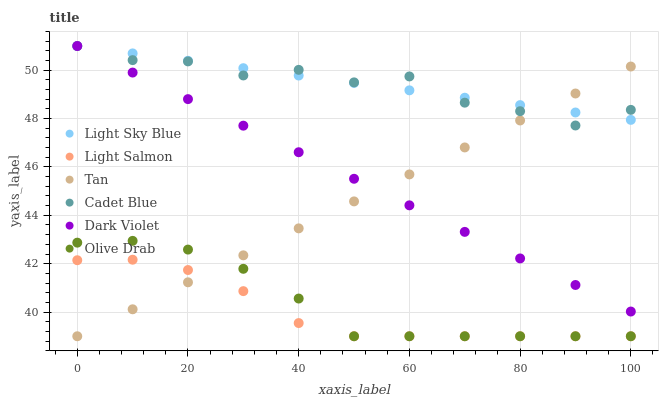Does Light Salmon have the minimum area under the curve?
Answer yes or no. Yes. Does Light Sky Blue have the maximum area under the curve?
Answer yes or no. Yes. Does Cadet Blue have the minimum area under the curve?
Answer yes or no. No. Does Cadet Blue have the maximum area under the curve?
Answer yes or no. No. Is Tan the smoothest?
Answer yes or no. Yes. Is Cadet Blue the roughest?
Answer yes or no. Yes. Is Dark Violet the smoothest?
Answer yes or no. No. Is Dark Violet the roughest?
Answer yes or no. No. Does Light Salmon have the lowest value?
Answer yes or no. Yes. Does Cadet Blue have the lowest value?
Answer yes or no. No. Does Light Sky Blue have the highest value?
Answer yes or no. Yes. Does Tan have the highest value?
Answer yes or no. No. Is Light Salmon less than Cadet Blue?
Answer yes or no. Yes. Is Cadet Blue greater than Light Salmon?
Answer yes or no. Yes. Does Light Sky Blue intersect Dark Violet?
Answer yes or no. Yes. Is Light Sky Blue less than Dark Violet?
Answer yes or no. No. Is Light Sky Blue greater than Dark Violet?
Answer yes or no. No. Does Light Salmon intersect Cadet Blue?
Answer yes or no. No. 